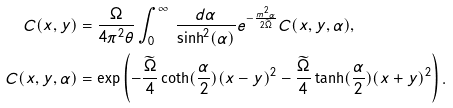<formula> <loc_0><loc_0><loc_500><loc_500>C ( x , y ) & = \frac { \Omega } { 4 \pi ^ { 2 } \theta } \int _ { 0 } ^ { \infty } \, \frac { d \alpha } { \sinh ^ { 2 } ( \alpha ) } e ^ { - \frac { m ^ { 2 } \alpha } { 2 \widetilde { \Omega } } } C ( x , y , \alpha ) , \\ C ( x , y , \alpha ) & = \exp \left ( - \frac { \widetilde { \Omega } } { 4 } \coth ( \frac { \alpha } { 2 } ) ( x - y ) ^ { 2 } - \frac { \widetilde { \Omega } } { 4 } \tanh ( \frac { \alpha } { 2 } ) ( x + y ) ^ { 2 } \right ) .</formula> 